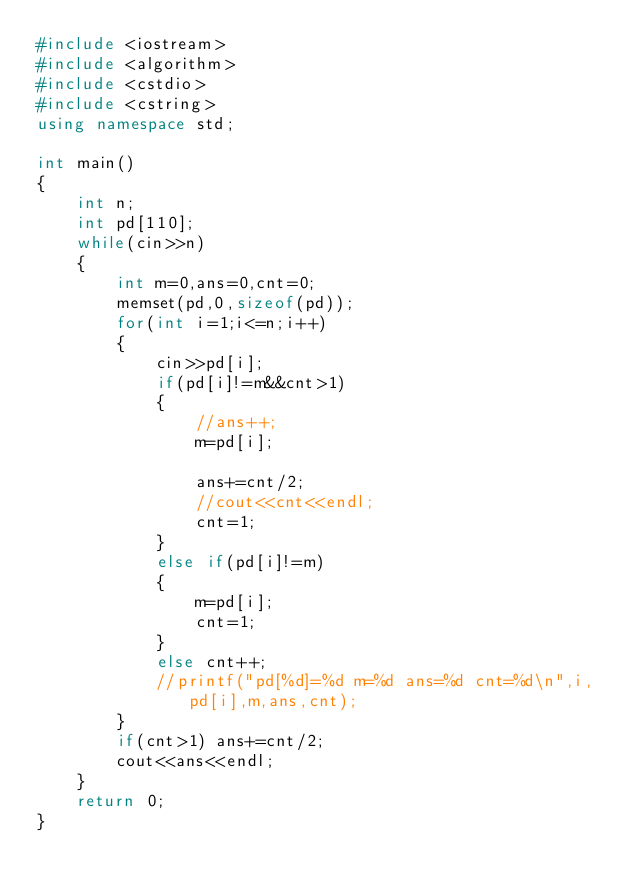Convert code to text. <code><loc_0><loc_0><loc_500><loc_500><_C++_>#include <iostream>
#include <algorithm>
#include <cstdio>
#include <cstring>
using namespace std;

int main()
{
    int n;
    int pd[110];
    while(cin>>n)
    {
        int m=0,ans=0,cnt=0;
        memset(pd,0,sizeof(pd));
        for(int i=1;i<=n;i++)
        {
            cin>>pd[i];
            if(pd[i]!=m&&cnt>1)
            {
                //ans++;
                m=pd[i];

                ans+=cnt/2;
                //cout<<cnt<<endl;
                cnt=1;
            }
            else if(pd[i]!=m)
            {
                m=pd[i];
                cnt=1;
            }
            else cnt++;
            //printf("pd[%d]=%d m=%d ans=%d cnt=%d\n",i,pd[i],m,ans,cnt);
        }
        if(cnt>1) ans+=cnt/2;
        cout<<ans<<endl;
    }
    return 0;
}
</code> 